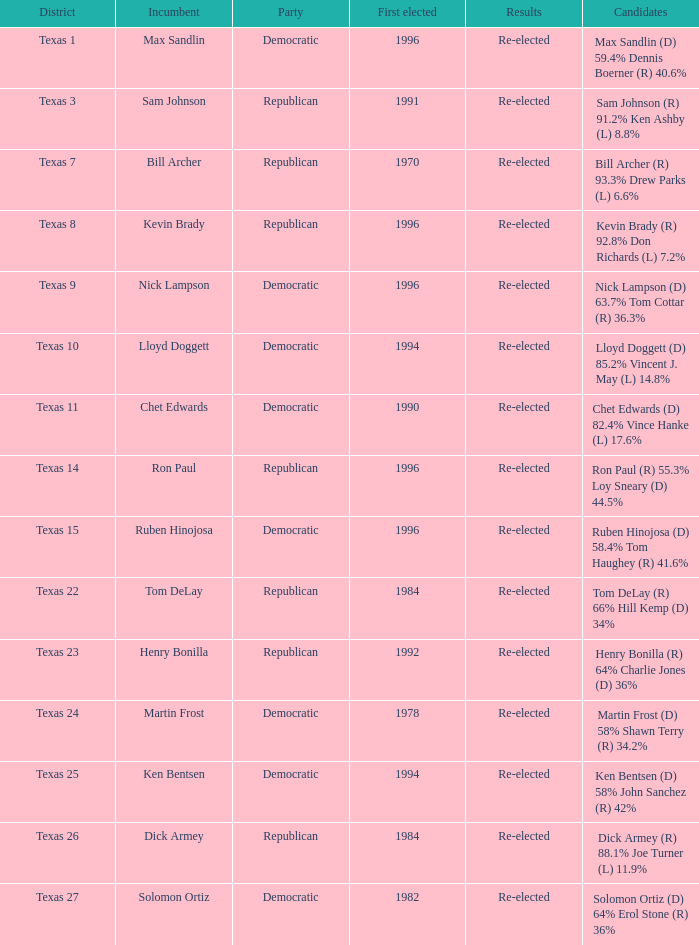How many times did incumbent ruben hinojosa get elected? 1.0. 